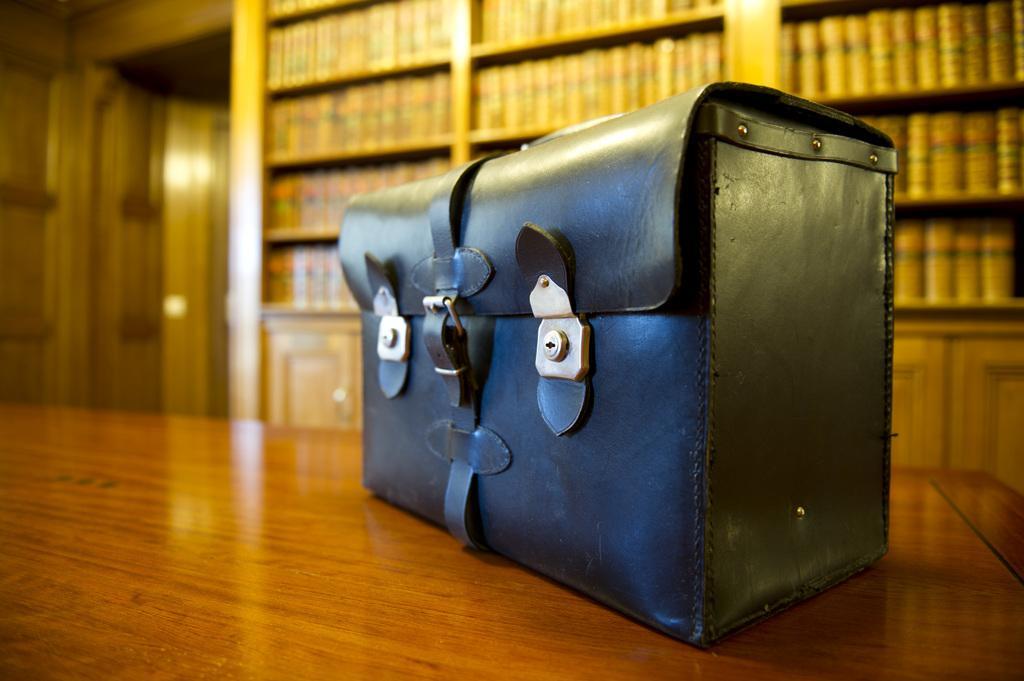Could you give a brief overview of what you see in this image? In this image there is a black bag on the table. In the background there are books in rack and a door. 